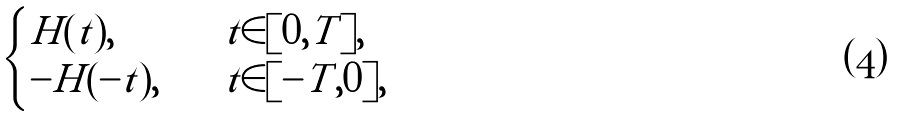Convert formula to latex. <formula><loc_0><loc_0><loc_500><loc_500>\begin{cases} H ( t ) , \quad & t \in [ 0 , T ] , \\ - H ( - t ) , \quad & t \in [ - T , 0 ] , \end{cases}</formula> 